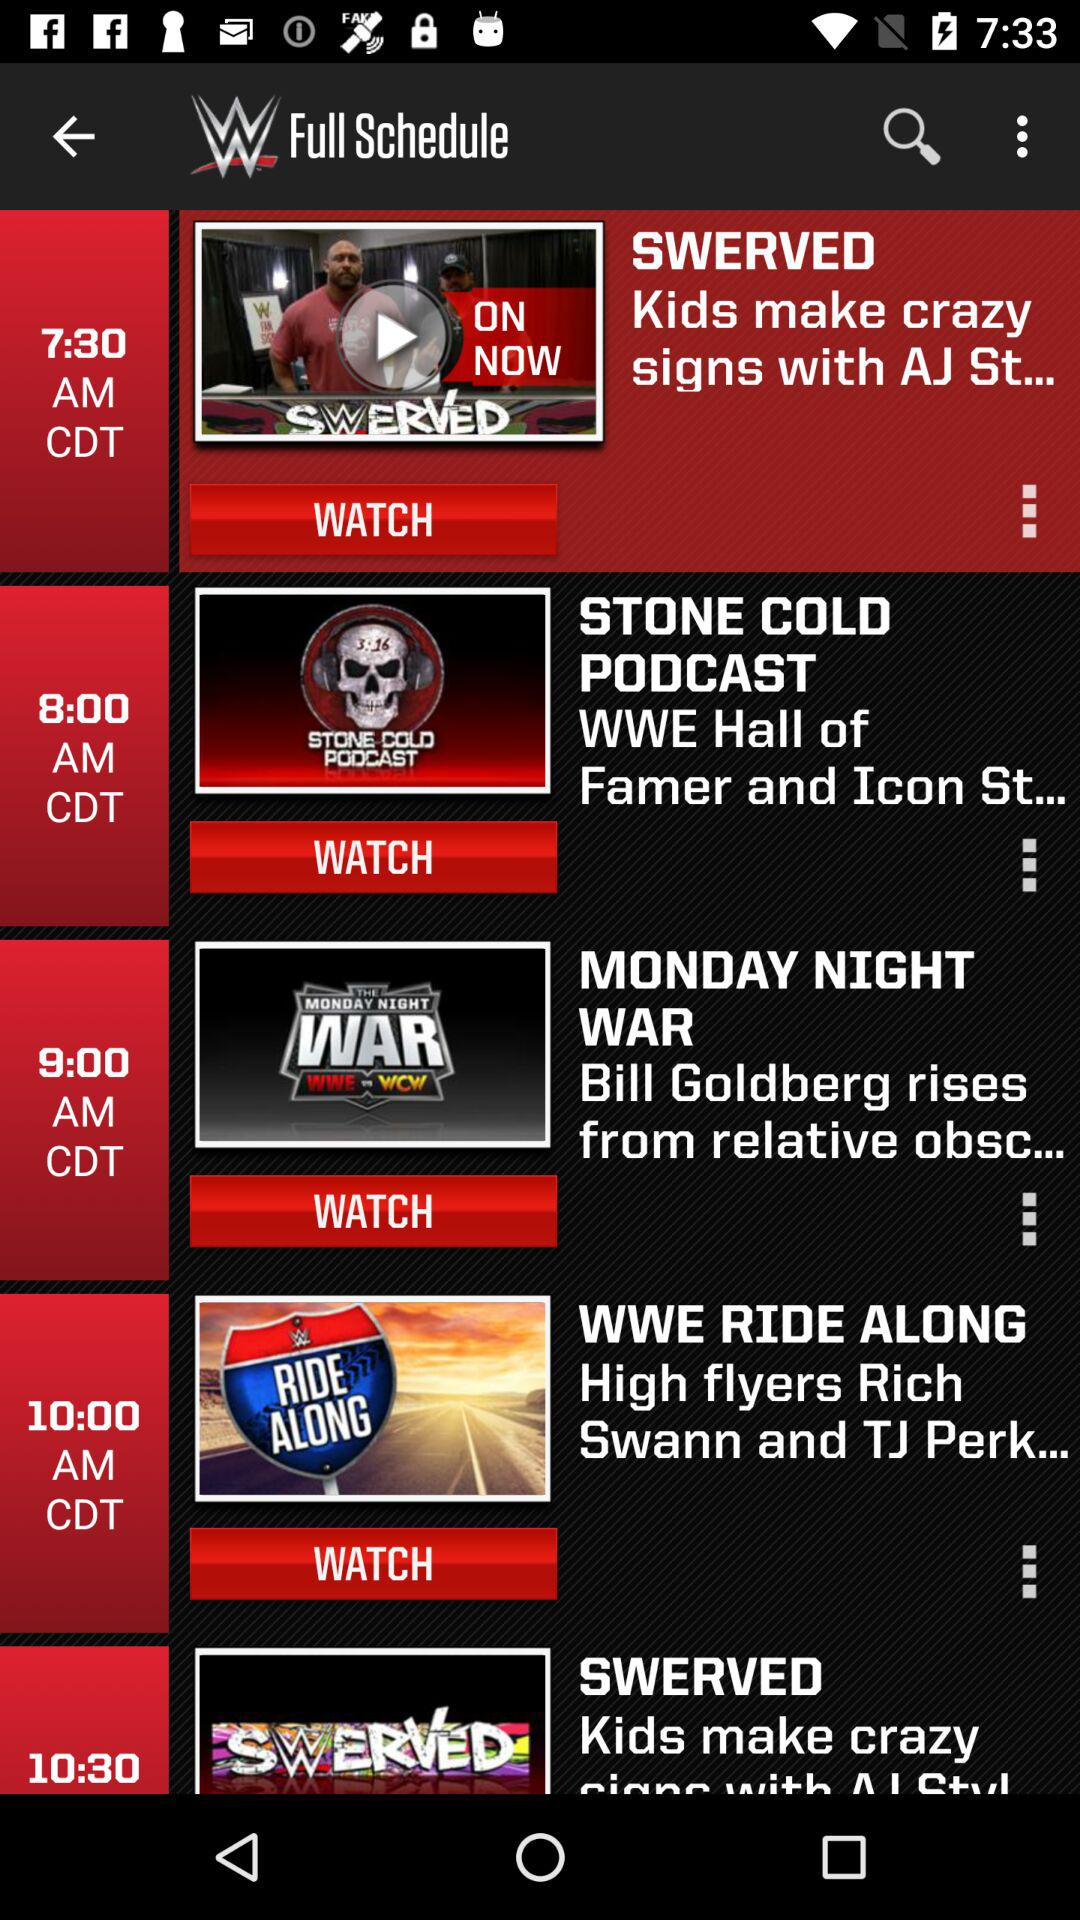How many hours are between the first and last item?
Answer the question using a single word or phrase. 3 